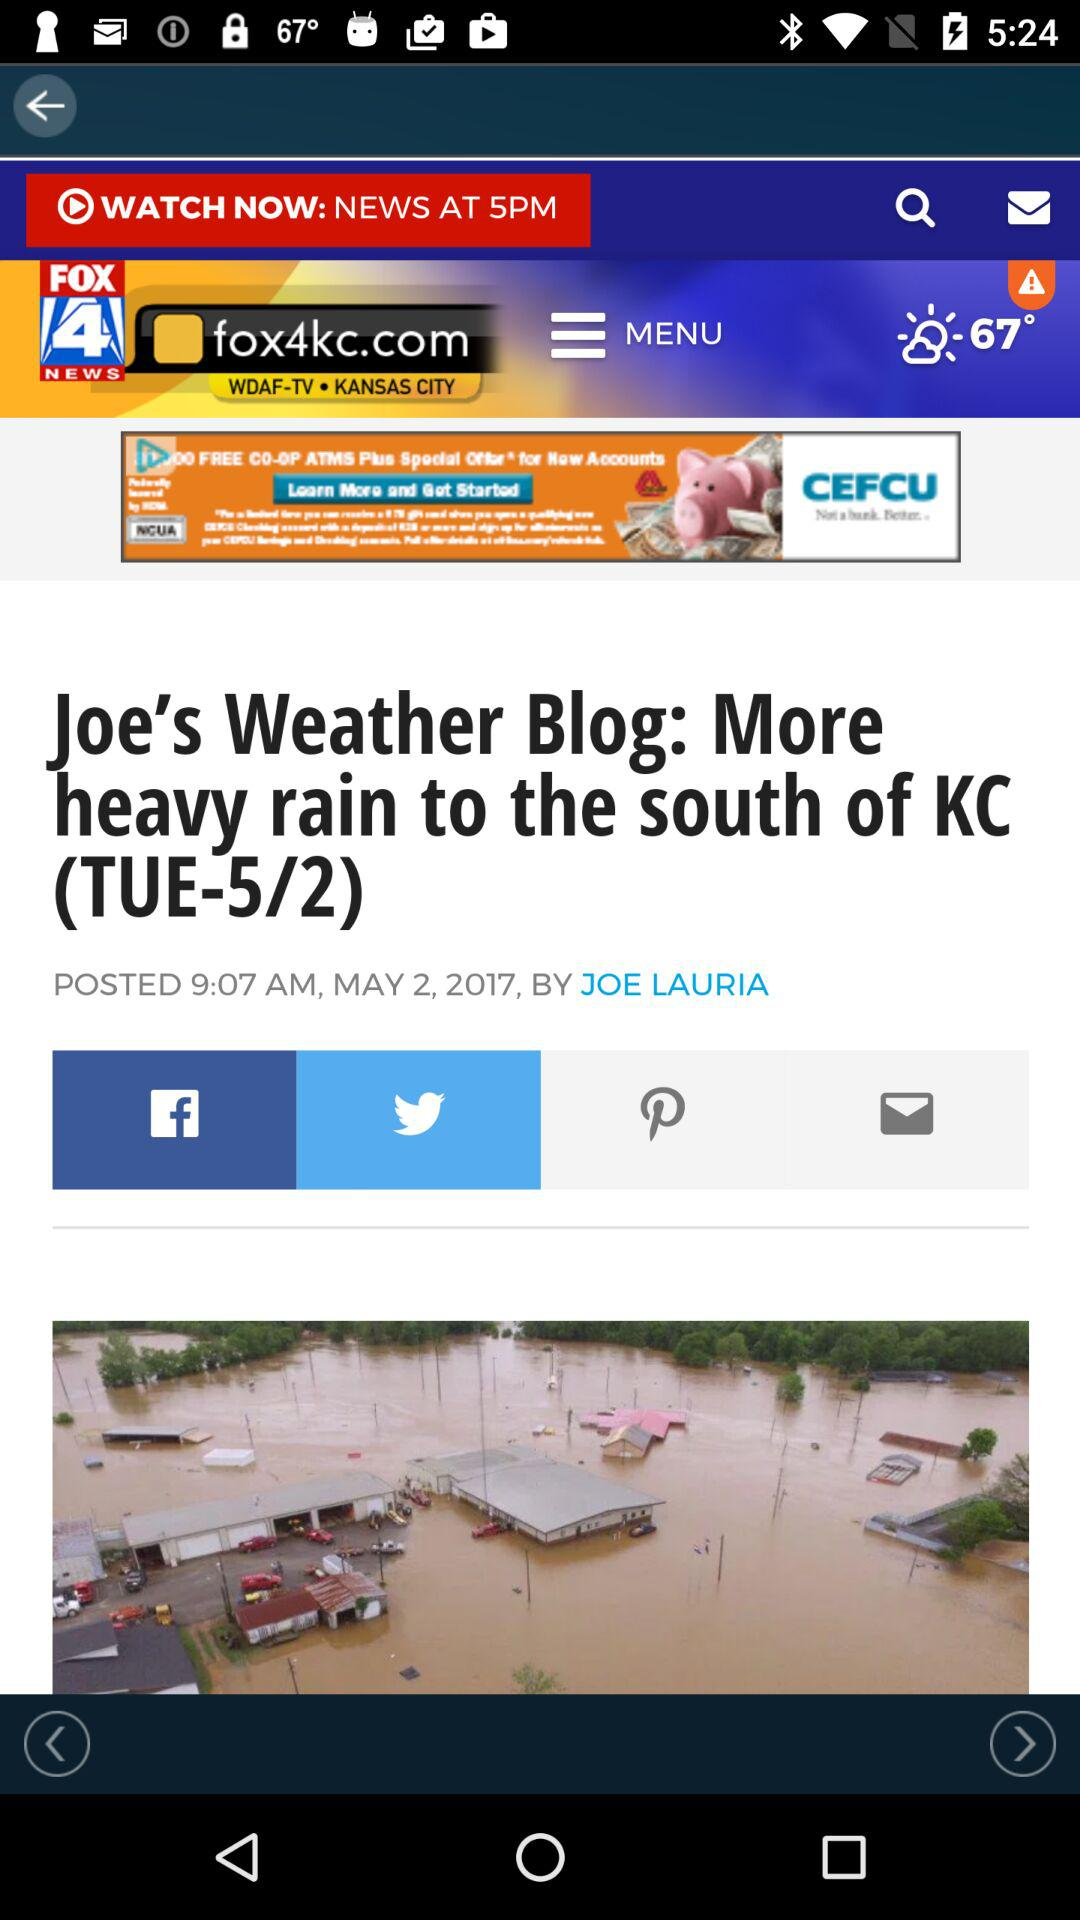Who wrote the story? The story was written by Joe Lauria. 